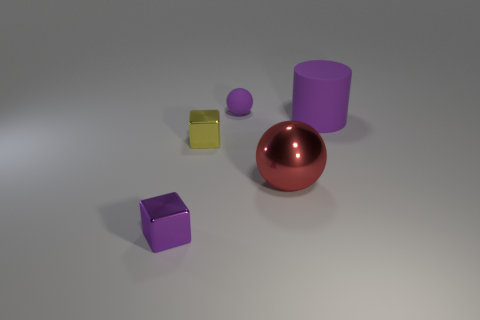Subtract all cylinders. How many objects are left? 4 Add 1 tiny yellow matte spheres. How many objects exist? 6 Add 4 tiny purple matte spheres. How many tiny purple matte spheres are left? 5 Add 3 small cyan rubber spheres. How many small cyan rubber spheres exist? 3 Subtract 0 cyan blocks. How many objects are left? 5 Subtract all yellow objects. Subtract all tiny blue matte cylinders. How many objects are left? 4 